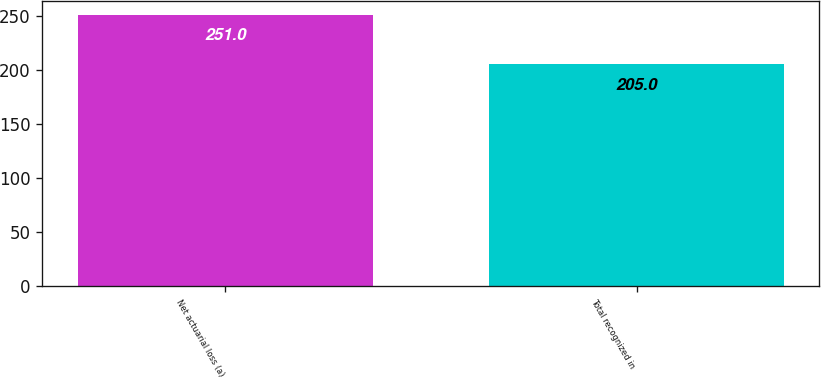Convert chart. <chart><loc_0><loc_0><loc_500><loc_500><bar_chart><fcel>Net actuarial loss (a)<fcel>Total recognized in<nl><fcel>251<fcel>205<nl></chart> 